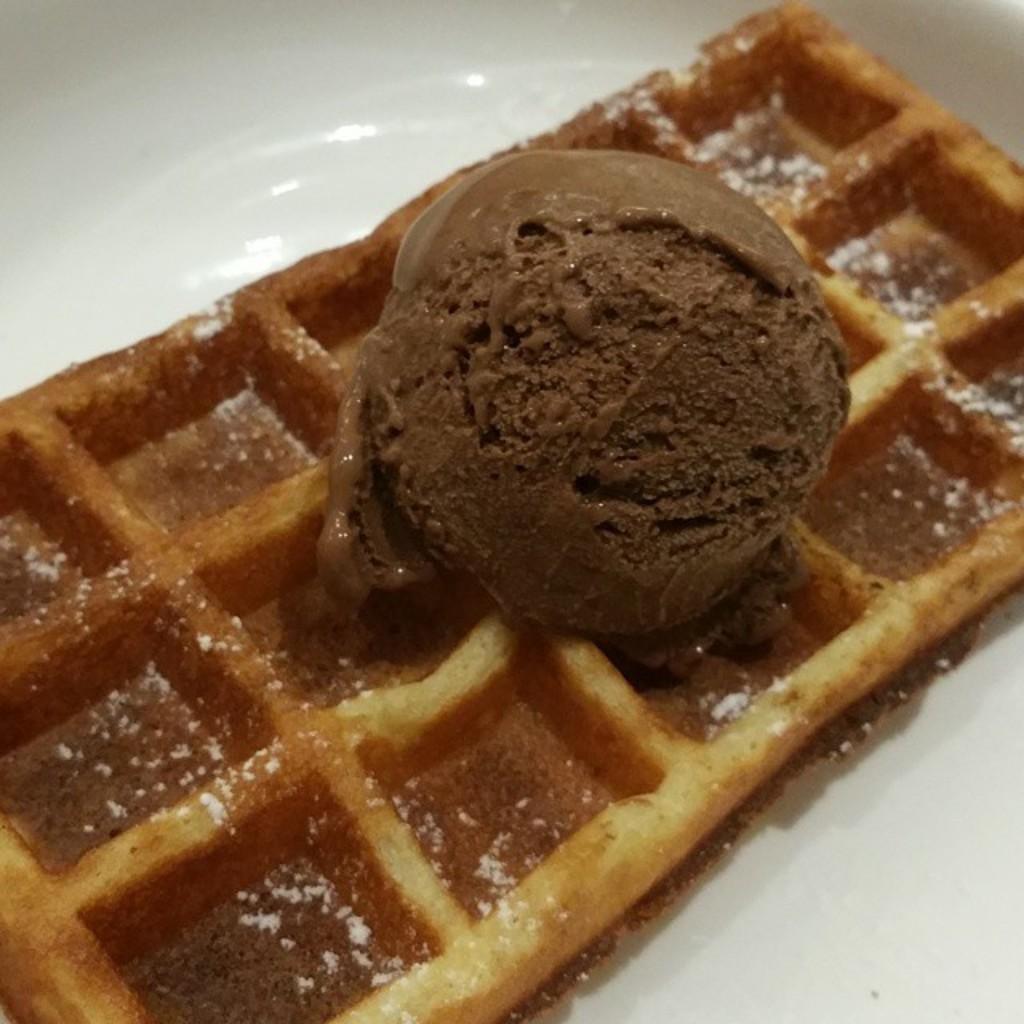Please provide a concise description of this image. In this image I can see an ice cream and wafer in the plate. The ice cream is in brown color and the plate is in white color. 